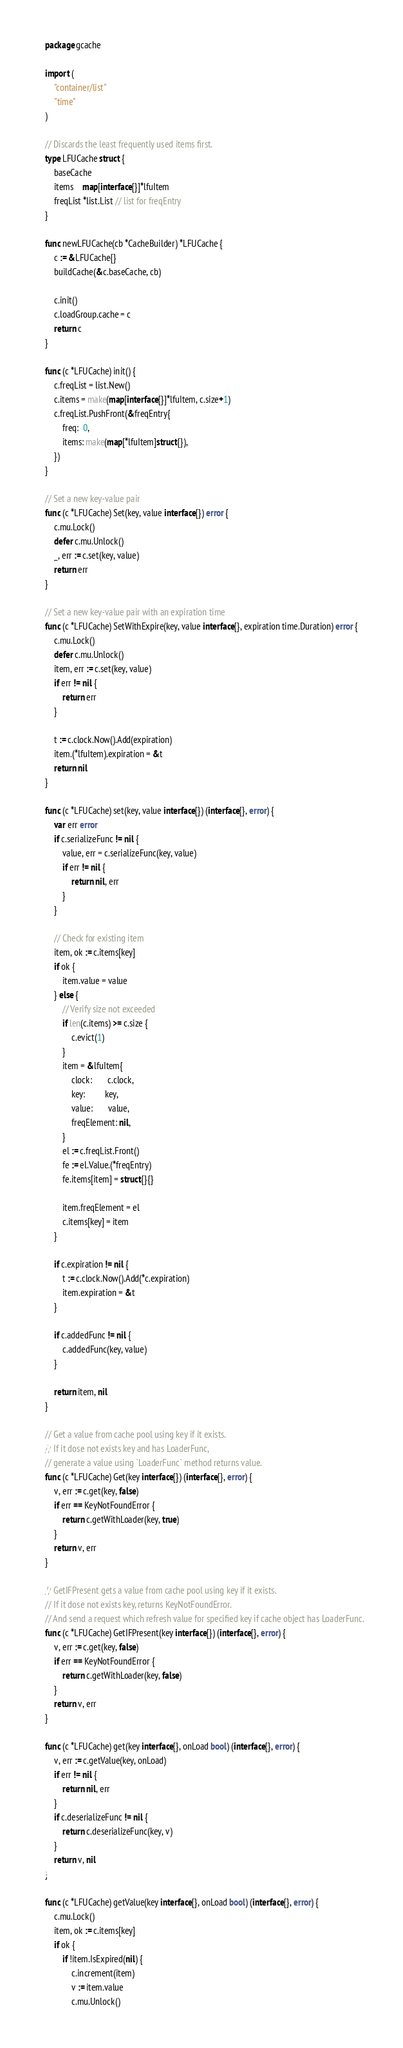Convert code to text. <code><loc_0><loc_0><loc_500><loc_500><_Go_>package gcache

import (
	"container/list"
	"time"
)

// Discards the least frequently used items first.
type LFUCache struct {
	baseCache
	items    map[interface{}]*lfuItem
	freqList *list.List // list for freqEntry
}

func newLFUCache(cb *CacheBuilder) *LFUCache {
	c := &LFUCache{}
	buildCache(&c.baseCache, cb)

	c.init()
	c.loadGroup.cache = c
	return c
}

func (c *LFUCache) init() {
	c.freqList = list.New()
	c.items = make(map[interface{}]*lfuItem, c.size+1)
	c.freqList.PushFront(&freqEntry{
		freq:  0,
		items: make(map[*lfuItem]struct{}),
	})
}

// Set a new key-value pair
func (c *LFUCache) Set(key, value interface{}) error {
	c.mu.Lock()
	defer c.mu.Unlock()
	_, err := c.set(key, value)
	return err
}

// Set a new key-value pair with an expiration time
func (c *LFUCache) SetWithExpire(key, value interface{}, expiration time.Duration) error {
	c.mu.Lock()
	defer c.mu.Unlock()
	item, err := c.set(key, value)
	if err != nil {
		return err
	}

	t := c.clock.Now().Add(expiration)
	item.(*lfuItem).expiration = &t
	return nil
}

func (c *LFUCache) set(key, value interface{}) (interface{}, error) {
	var err error
	if c.serializeFunc != nil {
		value, err = c.serializeFunc(key, value)
		if err != nil {
			return nil, err
		}
	}

	// Check for existing item
	item, ok := c.items[key]
	if ok {
		item.value = value
	} else {
		// Verify size not exceeded
		if len(c.items) >= c.size {
			c.evict(1)
		}
		item = &lfuItem{
			clock:       c.clock,
			key:         key,
			value:       value,
			freqElement: nil,
		}
		el := c.freqList.Front()
		fe := el.Value.(*freqEntry)
		fe.items[item] = struct{}{}

		item.freqElement = el
		c.items[key] = item
	}

	if c.expiration != nil {
		t := c.clock.Now().Add(*c.expiration)
		item.expiration = &t
	}

	if c.addedFunc != nil {
		c.addedFunc(key, value)
	}

	return item, nil
}

// Get a value from cache pool using key if it exists.
// If it dose not exists key and has LoaderFunc,
// generate a value using `LoaderFunc` method returns value.
func (c *LFUCache) Get(key interface{}) (interface{}, error) {
	v, err := c.get(key, false)
	if err == KeyNotFoundError {
		return c.getWithLoader(key, true)
	}
	return v, err
}

// GetIFPresent gets a value from cache pool using key if it exists.
// If it dose not exists key, returns KeyNotFoundError.
// And send a request which refresh value for specified key if cache object has LoaderFunc.
func (c *LFUCache) GetIFPresent(key interface{}) (interface{}, error) {
	v, err := c.get(key, false)
	if err == KeyNotFoundError {
		return c.getWithLoader(key, false)
	}
	return v, err
}

func (c *LFUCache) get(key interface{}, onLoad bool) (interface{}, error) {
	v, err := c.getValue(key, onLoad)
	if err != nil {
		return nil, err
	}
	if c.deserializeFunc != nil {
		return c.deserializeFunc(key, v)
	}
	return v, nil
}

func (c *LFUCache) getValue(key interface{}, onLoad bool) (interface{}, error) {
	c.mu.Lock()
	item, ok := c.items[key]
	if ok {
		if !item.IsExpired(nil) {
			c.increment(item)
			v := item.value
			c.mu.Unlock()</code> 